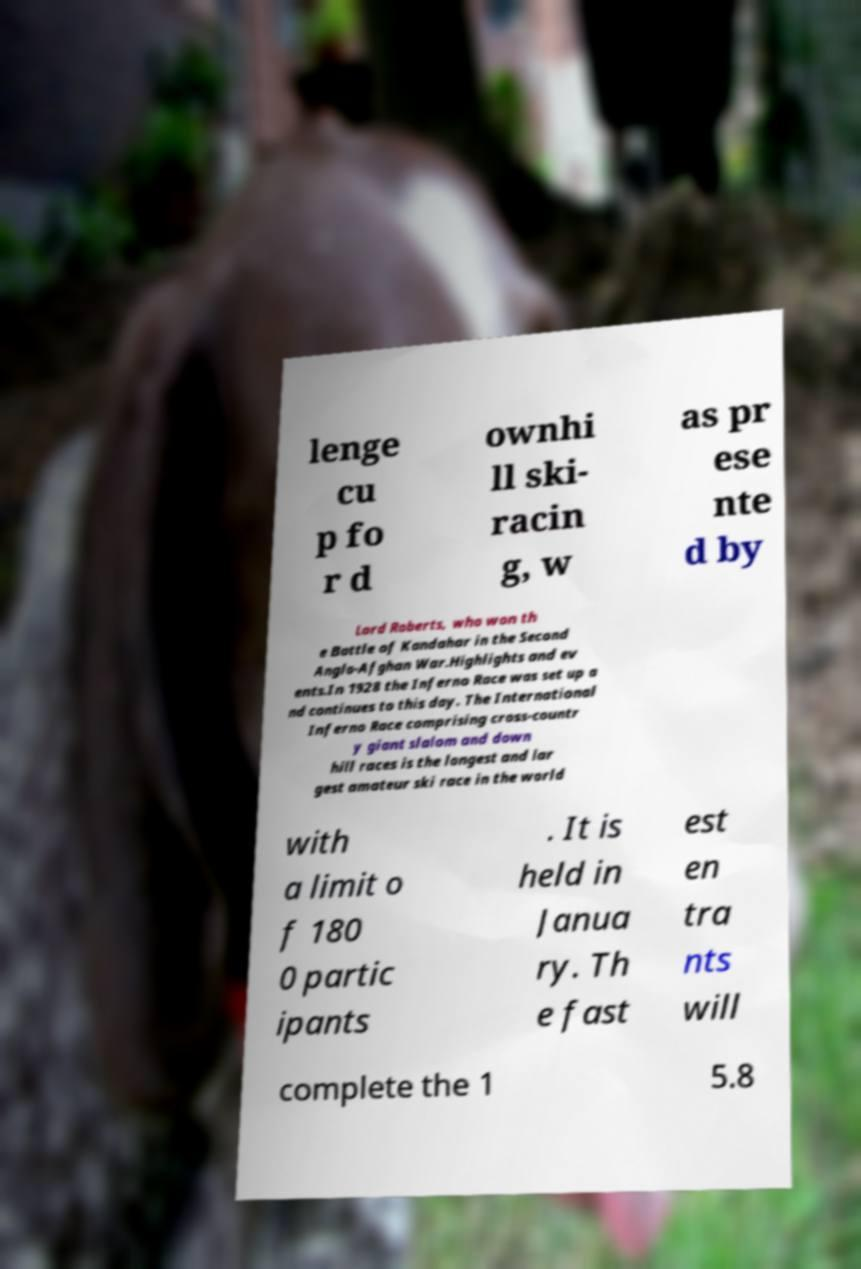Can you accurately transcribe the text from the provided image for me? lenge cu p fo r d ownhi ll ski- racin g, w as pr ese nte d by Lord Roberts, who won th e Battle of Kandahar in the Second Anglo-Afghan War.Highlights and ev ents.In 1928 the Inferno Race was set up a nd continues to this day. The International Inferno Race comprising cross-countr y giant slalom and down hill races is the longest and lar gest amateur ski race in the world with a limit o f 180 0 partic ipants . It is held in Janua ry. Th e fast est en tra nts will complete the 1 5.8 